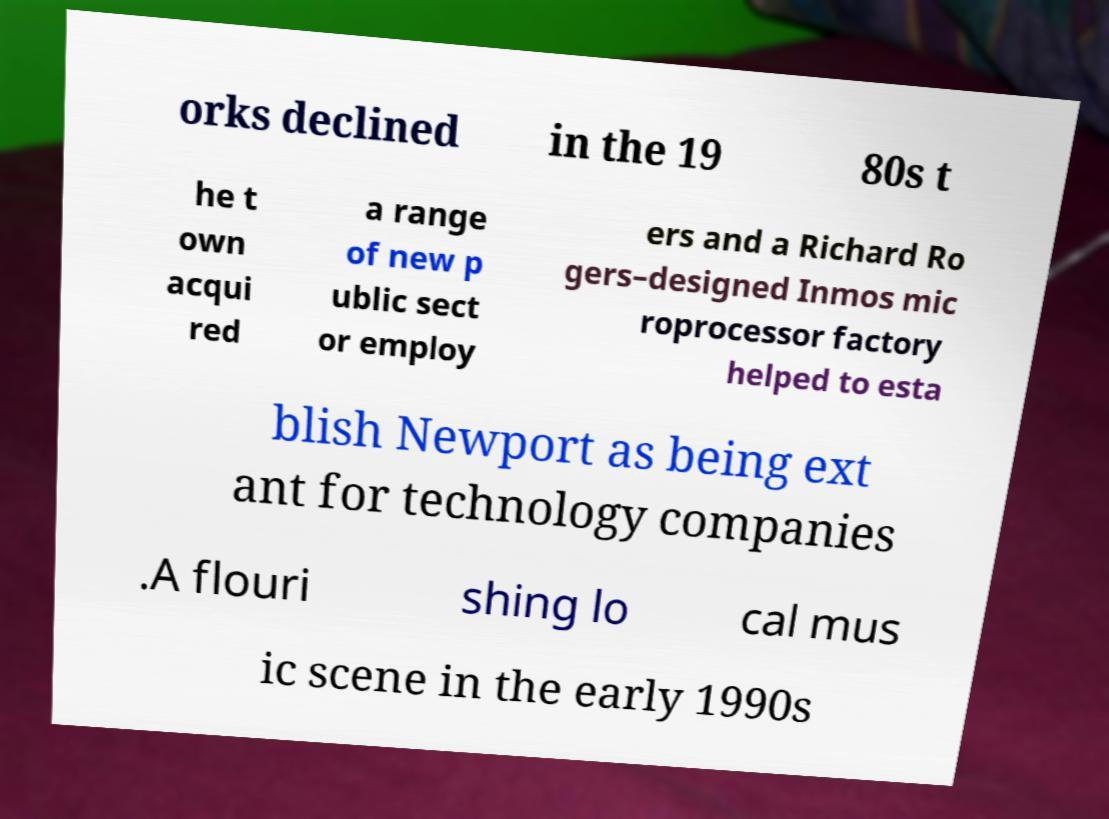Can you read and provide the text displayed in the image?This photo seems to have some interesting text. Can you extract and type it out for me? orks declined in the 19 80s t he t own acqui red a range of new p ublic sect or employ ers and a Richard Ro gers–designed Inmos mic roprocessor factory helped to esta blish Newport as being ext ant for technology companies .A flouri shing lo cal mus ic scene in the early 1990s 